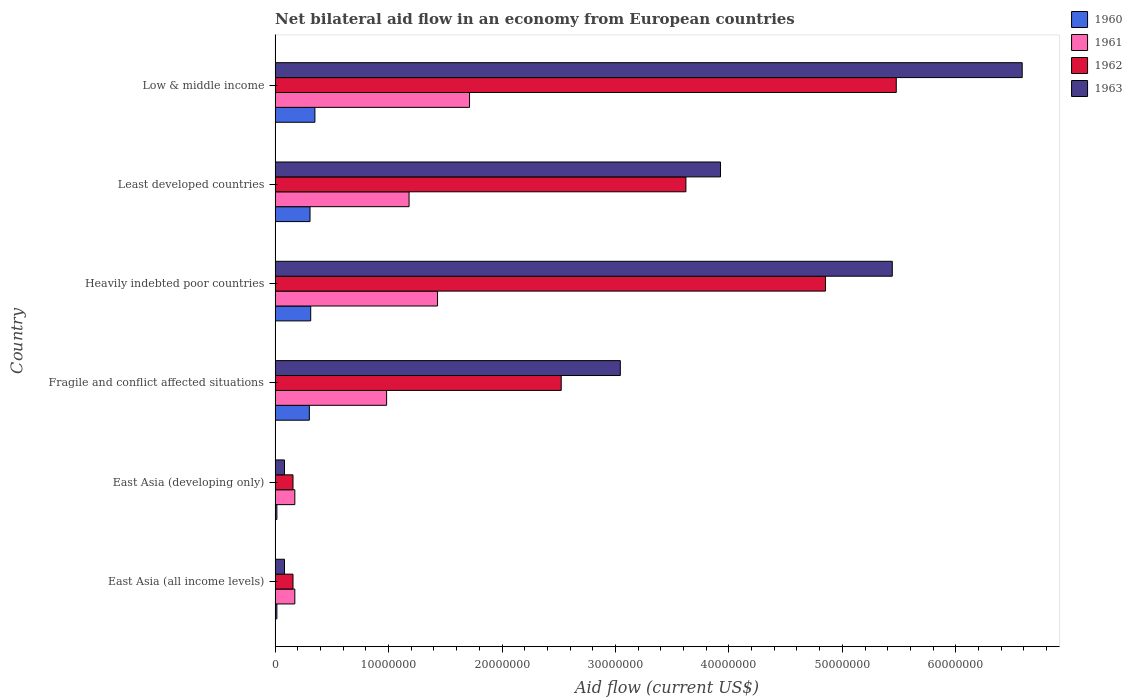How many groups of bars are there?
Your answer should be very brief. 6. Are the number of bars per tick equal to the number of legend labels?
Your answer should be very brief. Yes. Are the number of bars on each tick of the Y-axis equal?
Your response must be concise. Yes. How many bars are there on the 5th tick from the top?
Ensure brevity in your answer.  4. How many bars are there on the 5th tick from the bottom?
Keep it short and to the point. 4. In how many cases, is the number of bars for a given country not equal to the number of legend labels?
Make the answer very short. 0. What is the net bilateral aid flow in 1963 in Low & middle income?
Provide a succinct answer. 6.58e+07. Across all countries, what is the maximum net bilateral aid flow in 1963?
Provide a short and direct response. 6.58e+07. Across all countries, what is the minimum net bilateral aid flow in 1963?
Offer a very short reply. 8.30e+05. In which country was the net bilateral aid flow in 1963 minimum?
Your response must be concise. East Asia (all income levels). What is the total net bilateral aid flow in 1961 in the graph?
Your answer should be very brief. 5.66e+07. What is the difference between the net bilateral aid flow in 1961 in Heavily indebted poor countries and that in Least developed countries?
Your answer should be compact. 2.51e+06. What is the difference between the net bilateral aid flow in 1962 in Low & middle income and the net bilateral aid flow in 1963 in East Asia (all income levels)?
Your answer should be very brief. 5.39e+07. What is the average net bilateral aid flow in 1963 per country?
Provide a short and direct response. 3.19e+07. What is the difference between the net bilateral aid flow in 1960 and net bilateral aid flow in 1961 in Fragile and conflict affected situations?
Ensure brevity in your answer.  -6.81e+06. In how many countries, is the net bilateral aid flow in 1962 greater than 54000000 US$?
Keep it short and to the point. 1. What is the ratio of the net bilateral aid flow in 1960 in East Asia (developing only) to that in Least developed countries?
Provide a short and direct response. 0.05. What is the difference between the highest and the lowest net bilateral aid flow in 1963?
Make the answer very short. 6.50e+07. Is it the case that in every country, the sum of the net bilateral aid flow in 1960 and net bilateral aid flow in 1962 is greater than the sum of net bilateral aid flow in 1961 and net bilateral aid flow in 1963?
Provide a short and direct response. No. How many bars are there?
Keep it short and to the point. 24. How many countries are there in the graph?
Offer a terse response. 6. What is the difference between two consecutive major ticks on the X-axis?
Offer a very short reply. 1.00e+07. What is the title of the graph?
Your answer should be very brief. Net bilateral aid flow in an economy from European countries. Does "1986" appear as one of the legend labels in the graph?
Ensure brevity in your answer.  No. What is the label or title of the X-axis?
Offer a very short reply. Aid flow (current US$). What is the label or title of the Y-axis?
Ensure brevity in your answer.  Country. What is the Aid flow (current US$) of 1961 in East Asia (all income levels)?
Provide a succinct answer. 1.74e+06. What is the Aid flow (current US$) in 1962 in East Asia (all income levels)?
Ensure brevity in your answer.  1.58e+06. What is the Aid flow (current US$) in 1963 in East Asia (all income levels)?
Make the answer very short. 8.30e+05. What is the Aid flow (current US$) in 1961 in East Asia (developing only)?
Your response must be concise. 1.74e+06. What is the Aid flow (current US$) in 1962 in East Asia (developing only)?
Your answer should be compact. 1.58e+06. What is the Aid flow (current US$) of 1963 in East Asia (developing only)?
Provide a short and direct response. 8.30e+05. What is the Aid flow (current US$) of 1960 in Fragile and conflict affected situations?
Your response must be concise. 3.02e+06. What is the Aid flow (current US$) of 1961 in Fragile and conflict affected situations?
Give a very brief answer. 9.83e+06. What is the Aid flow (current US$) of 1962 in Fragile and conflict affected situations?
Your answer should be very brief. 2.52e+07. What is the Aid flow (current US$) in 1963 in Fragile and conflict affected situations?
Provide a succinct answer. 3.04e+07. What is the Aid flow (current US$) of 1960 in Heavily indebted poor countries?
Offer a very short reply. 3.14e+06. What is the Aid flow (current US$) in 1961 in Heavily indebted poor countries?
Give a very brief answer. 1.43e+07. What is the Aid flow (current US$) of 1962 in Heavily indebted poor countries?
Ensure brevity in your answer.  4.85e+07. What is the Aid flow (current US$) in 1963 in Heavily indebted poor countries?
Keep it short and to the point. 5.44e+07. What is the Aid flow (current US$) of 1960 in Least developed countries?
Ensure brevity in your answer.  3.08e+06. What is the Aid flow (current US$) of 1961 in Least developed countries?
Offer a very short reply. 1.18e+07. What is the Aid flow (current US$) of 1962 in Least developed countries?
Provide a succinct answer. 3.62e+07. What is the Aid flow (current US$) of 1963 in Least developed countries?
Make the answer very short. 3.93e+07. What is the Aid flow (current US$) in 1960 in Low & middle income?
Offer a very short reply. 3.51e+06. What is the Aid flow (current US$) in 1961 in Low & middle income?
Give a very brief answer. 1.71e+07. What is the Aid flow (current US$) of 1962 in Low & middle income?
Your response must be concise. 5.48e+07. What is the Aid flow (current US$) of 1963 in Low & middle income?
Make the answer very short. 6.58e+07. Across all countries, what is the maximum Aid flow (current US$) of 1960?
Provide a succinct answer. 3.51e+06. Across all countries, what is the maximum Aid flow (current US$) of 1961?
Your answer should be very brief. 1.71e+07. Across all countries, what is the maximum Aid flow (current US$) in 1962?
Your response must be concise. 5.48e+07. Across all countries, what is the maximum Aid flow (current US$) of 1963?
Offer a very short reply. 6.58e+07. Across all countries, what is the minimum Aid flow (current US$) in 1961?
Your response must be concise. 1.74e+06. Across all countries, what is the minimum Aid flow (current US$) in 1962?
Your answer should be compact. 1.58e+06. Across all countries, what is the minimum Aid flow (current US$) in 1963?
Your answer should be very brief. 8.30e+05. What is the total Aid flow (current US$) of 1960 in the graph?
Ensure brevity in your answer.  1.31e+07. What is the total Aid flow (current US$) in 1961 in the graph?
Keep it short and to the point. 5.66e+07. What is the total Aid flow (current US$) in 1962 in the graph?
Your response must be concise. 1.68e+08. What is the total Aid flow (current US$) in 1963 in the graph?
Your answer should be compact. 1.92e+08. What is the difference between the Aid flow (current US$) of 1961 in East Asia (all income levels) and that in East Asia (developing only)?
Offer a terse response. 0. What is the difference between the Aid flow (current US$) in 1962 in East Asia (all income levels) and that in East Asia (developing only)?
Make the answer very short. 0. What is the difference between the Aid flow (current US$) in 1963 in East Asia (all income levels) and that in East Asia (developing only)?
Your answer should be very brief. 0. What is the difference between the Aid flow (current US$) of 1960 in East Asia (all income levels) and that in Fragile and conflict affected situations?
Provide a short and direct response. -2.86e+06. What is the difference between the Aid flow (current US$) in 1961 in East Asia (all income levels) and that in Fragile and conflict affected situations?
Give a very brief answer. -8.09e+06. What is the difference between the Aid flow (current US$) in 1962 in East Asia (all income levels) and that in Fragile and conflict affected situations?
Your answer should be compact. -2.36e+07. What is the difference between the Aid flow (current US$) of 1963 in East Asia (all income levels) and that in Fragile and conflict affected situations?
Provide a short and direct response. -2.96e+07. What is the difference between the Aid flow (current US$) in 1960 in East Asia (all income levels) and that in Heavily indebted poor countries?
Give a very brief answer. -2.98e+06. What is the difference between the Aid flow (current US$) of 1961 in East Asia (all income levels) and that in Heavily indebted poor countries?
Offer a terse response. -1.26e+07. What is the difference between the Aid flow (current US$) of 1962 in East Asia (all income levels) and that in Heavily indebted poor countries?
Provide a short and direct response. -4.69e+07. What is the difference between the Aid flow (current US$) of 1963 in East Asia (all income levels) and that in Heavily indebted poor countries?
Give a very brief answer. -5.36e+07. What is the difference between the Aid flow (current US$) in 1960 in East Asia (all income levels) and that in Least developed countries?
Ensure brevity in your answer.  -2.92e+06. What is the difference between the Aid flow (current US$) in 1961 in East Asia (all income levels) and that in Least developed countries?
Offer a terse response. -1.01e+07. What is the difference between the Aid flow (current US$) of 1962 in East Asia (all income levels) and that in Least developed countries?
Your answer should be compact. -3.46e+07. What is the difference between the Aid flow (current US$) in 1963 in East Asia (all income levels) and that in Least developed countries?
Provide a short and direct response. -3.84e+07. What is the difference between the Aid flow (current US$) of 1960 in East Asia (all income levels) and that in Low & middle income?
Your response must be concise. -3.35e+06. What is the difference between the Aid flow (current US$) of 1961 in East Asia (all income levels) and that in Low & middle income?
Your answer should be compact. -1.54e+07. What is the difference between the Aid flow (current US$) of 1962 in East Asia (all income levels) and that in Low & middle income?
Provide a succinct answer. -5.32e+07. What is the difference between the Aid flow (current US$) in 1963 in East Asia (all income levels) and that in Low & middle income?
Keep it short and to the point. -6.50e+07. What is the difference between the Aid flow (current US$) of 1960 in East Asia (developing only) and that in Fragile and conflict affected situations?
Make the answer very short. -2.86e+06. What is the difference between the Aid flow (current US$) of 1961 in East Asia (developing only) and that in Fragile and conflict affected situations?
Ensure brevity in your answer.  -8.09e+06. What is the difference between the Aid flow (current US$) of 1962 in East Asia (developing only) and that in Fragile and conflict affected situations?
Keep it short and to the point. -2.36e+07. What is the difference between the Aid flow (current US$) of 1963 in East Asia (developing only) and that in Fragile and conflict affected situations?
Your answer should be very brief. -2.96e+07. What is the difference between the Aid flow (current US$) in 1960 in East Asia (developing only) and that in Heavily indebted poor countries?
Give a very brief answer. -2.98e+06. What is the difference between the Aid flow (current US$) in 1961 in East Asia (developing only) and that in Heavily indebted poor countries?
Ensure brevity in your answer.  -1.26e+07. What is the difference between the Aid flow (current US$) in 1962 in East Asia (developing only) and that in Heavily indebted poor countries?
Make the answer very short. -4.69e+07. What is the difference between the Aid flow (current US$) in 1963 in East Asia (developing only) and that in Heavily indebted poor countries?
Make the answer very short. -5.36e+07. What is the difference between the Aid flow (current US$) in 1960 in East Asia (developing only) and that in Least developed countries?
Keep it short and to the point. -2.92e+06. What is the difference between the Aid flow (current US$) of 1961 in East Asia (developing only) and that in Least developed countries?
Provide a succinct answer. -1.01e+07. What is the difference between the Aid flow (current US$) in 1962 in East Asia (developing only) and that in Least developed countries?
Keep it short and to the point. -3.46e+07. What is the difference between the Aid flow (current US$) of 1963 in East Asia (developing only) and that in Least developed countries?
Provide a short and direct response. -3.84e+07. What is the difference between the Aid flow (current US$) of 1960 in East Asia (developing only) and that in Low & middle income?
Make the answer very short. -3.35e+06. What is the difference between the Aid flow (current US$) in 1961 in East Asia (developing only) and that in Low & middle income?
Your answer should be compact. -1.54e+07. What is the difference between the Aid flow (current US$) of 1962 in East Asia (developing only) and that in Low & middle income?
Your answer should be compact. -5.32e+07. What is the difference between the Aid flow (current US$) of 1963 in East Asia (developing only) and that in Low & middle income?
Your answer should be compact. -6.50e+07. What is the difference between the Aid flow (current US$) in 1960 in Fragile and conflict affected situations and that in Heavily indebted poor countries?
Your answer should be compact. -1.20e+05. What is the difference between the Aid flow (current US$) of 1961 in Fragile and conflict affected situations and that in Heavily indebted poor countries?
Keep it short and to the point. -4.49e+06. What is the difference between the Aid flow (current US$) in 1962 in Fragile and conflict affected situations and that in Heavily indebted poor countries?
Provide a short and direct response. -2.33e+07. What is the difference between the Aid flow (current US$) of 1963 in Fragile and conflict affected situations and that in Heavily indebted poor countries?
Offer a terse response. -2.40e+07. What is the difference between the Aid flow (current US$) of 1960 in Fragile and conflict affected situations and that in Least developed countries?
Provide a succinct answer. -6.00e+04. What is the difference between the Aid flow (current US$) in 1961 in Fragile and conflict affected situations and that in Least developed countries?
Your response must be concise. -1.98e+06. What is the difference between the Aid flow (current US$) in 1962 in Fragile and conflict affected situations and that in Least developed countries?
Your answer should be compact. -1.10e+07. What is the difference between the Aid flow (current US$) in 1963 in Fragile and conflict affected situations and that in Least developed countries?
Your response must be concise. -8.83e+06. What is the difference between the Aid flow (current US$) of 1960 in Fragile and conflict affected situations and that in Low & middle income?
Offer a very short reply. -4.90e+05. What is the difference between the Aid flow (current US$) of 1961 in Fragile and conflict affected situations and that in Low & middle income?
Keep it short and to the point. -7.31e+06. What is the difference between the Aid flow (current US$) of 1962 in Fragile and conflict affected situations and that in Low & middle income?
Keep it short and to the point. -2.95e+07. What is the difference between the Aid flow (current US$) of 1963 in Fragile and conflict affected situations and that in Low & middle income?
Your answer should be compact. -3.54e+07. What is the difference between the Aid flow (current US$) of 1961 in Heavily indebted poor countries and that in Least developed countries?
Provide a succinct answer. 2.51e+06. What is the difference between the Aid flow (current US$) of 1962 in Heavily indebted poor countries and that in Least developed countries?
Your answer should be very brief. 1.23e+07. What is the difference between the Aid flow (current US$) of 1963 in Heavily indebted poor countries and that in Least developed countries?
Give a very brief answer. 1.51e+07. What is the difference between the Aid flow (current US$) in 1960 in Heavily indebted poor countries and that in Low & middle income?
Ensure brevity in your answer.  -3.70e+05. What is the difference between the Aid flow (current US$) in 1961 in Heavily indebted poor countries and that in Low & middle income?
Offer a terse response. -2.82e+06. What is the difference between the Aid flow (current US$) of 1962 in Heavily indebted poor countries and that in Low & middle income?
Keep it short and to the point. -6.24e+06. What is the difference between the Aid flow (current US$) of 1963 in Heavily indebted poor countries and that in Low & middle income?
Provide a short and direct response. -1.14e+07. What is the difference between the Aid flow (current US$) in 1960 in Least developed countries and that in Low & middle income?
Make the answer very short. -4.30e+05. What is the difference between the Aid flow (current US$) of 1961 in Least developed countries and that in Low & middle income?
Your answer should be very brief. -5.33e+06. What is the difference between the Aid flow (current US$) in 1962 in Least developed countries and that in Low & middle income?
Provide a short and direct response. -1.85e+07. What is the difference between the Aid flow (current US$) in 1963 in Least developed countries and that in Low & middle income?
Provide a succinct answer. -2.66e+07. What is the difference between the Aid flow (current US$) of 1960 in East Asia (all income levels) and the Aid flow (current US$) of 1961 in East Asia (developing only)?
Your response must be concise. -1.58e+06. What is the difference between the Aid flow (current US$) of 1960 in East Asia (all income levels) and the Aid flow (current US$) of 1962 in East Asia (developing only)?
Provide a short and direct response. -1.42e+06. What is the difference between the Aid flow (current US$) in 1960 in East Asia (all income levels) and the Aid flow (current US$) in 1963 in East Asia (developing only)?
Provide a succinct answer. -6.70e+05. What is the difference between the Aid flow (current US$) of 1961 in East Asia (all income levels) and the Aid flow (current US$) of 1963 in East Asia (developing only)?
Ensure brevity in your answer.  9.10e+05. What is the difference between the Aid flow (current US$) of 1962 in East Asia (all income levels) and the Aid flow (current US$) of 1963 in East Asia (developing only)?
Offer a very short reply. 7.50e+05. What is the difference between the Aid flow (current US$) of 1960 in East Asia (all income levels) and the Aid flow (current US$) of 1961 in Fragile and conflict affected situations?
Keep it short and to the point. -9.67e+06. What is the difference between the Aid flow (current US$) of 1960 in East Asia (all income levels) and the Aid flow (current US$) of 1962 in Fragile and conflict affected situations?
Your answer should be compact. -2.51e+07. What is the difference between the Aid flow (current US$) of 1960 in East Asia (all income levels) and the Aid flow (current US$) of 1963 in Fragile and conflict affected situations?
Offer a very short reply. -3.03e+07. What is the difference between the Aid flow (current US$) in 1961 in East Asia (all income levels) and the Aid flow (current US$) in 1962 in Fragile and conflict affected situations?
Your answer should be very brief. -2.35e+07. What is the difference between the Aid flow (current US$) of 1961 in East Asia (all income levels) and the Aid flow (current US$) of 1963 in Fragile and conflict affected situations?
Give a very brief answer. -2.87e+07. What is the difference between the Aid flow (current US$) in 1962 in East Asia (all income levels) and the Aid flow (current US$) in 1963 in Fragile and conflict affected situations?
Offer a very short reply. -2.88e+07. What is the difference between the Aid flow (current US$) in 1960 in East Asia (all income levels) and the Aid flow (current US$) in 1961 in Heavily indebted poor countries?
Your answer should be compact. -1.42e+07. What is the difference between the Aid flow (current US$) in 1960 in East Asia (all income levels) and the Aid flow (current US$) in 1962 in Heavily indebted poor countries?
Provide a short and direct response. -4.84e+07. What is the difference between the Aid flow (current US$) in 1960 in East Asia (all income levels) and the Aid flow (current US$) in 1963 in Heavily indebted poor countries?
Offer a very short reply. -5.42e+07. What is the difference between the Aid flow (current US$) in 1961 in East Asia (all income levels) and the Aid flow (current US$) in 1962 in Heavily indebted poor countries?
Offer a very short reply. -4.68e+07. What is the difference between the Aid flow (current US$) of 1961 in East Asia (all income levels) and the Aid flow (current US$) of 1963 in Heavily indebted poor countries?
Keep it short and to the point. -5.27e+07. What is the difference between the Aid flow (current US$) of 1962 in East Asia (all income levels) and the Aid flow (current US$) of 1963 in Heavily indebted poor countries?
Offer a very short reply. -5.28e+07. What is the difference between the Aid flow (current US$) in 1960 in East Asia (all income levels) and the Aid flow (current US$) in 1961 in Least developed countries?
Keep it short and to the point. -1.16e+07. What is the difference between the Aid flow (current US$) in 1960 in East Asia (all income levels) and the Aid flow (current US$) in 1962 in Least developed countries?
Make the answer very short. -3.60e+07. What is the difference between the Aid flow (current US$) of 1960 in East Asia (all income levels) and the Aid flow (current US$) of 1963 in Least developed countries?
Keep it short and to the point. -3.91e+07. What is the difference between the Aid flow (current US$) in 1961 in East Asia (all income levels) and the Aid flow (current US$) in 1962 in Least developed countries?
Ensure brevity in your answer.  -3.45e+07. What is the difference between the Aid flow (current US$) of 1961 in East Asia (all income levels) and the Aid flow (current US$) of 1963 in Least developed countries?
Keep it short and to the point. -3.75e+07. What is the difference between the Aid flow (current US$) of 1962 in East Asia (all income levels) and the Aid flow (current US$) of 1963 in Least developed countries?
Make the answer very short. -3.77e+07. What is the difference between the Aid flow (current US$) in 1960 in East Asia (all income levels) and the Aid flow (current US$) in 1961 in Low & middle income?
Keep it short and to the point. -1.70e+07. What is the difference between the Aid flow (current US$) of 1960 in East Asia (all income levels) and the Aid flow (current US$) of 1962 in Low & middle income?
Your answer should be compact. -5.46e+07. What is the difference between the Aid flow (current US$) of 1960 in East Asia (all income levels) and the Aid flow (current US$) of 1963 in Low & middle income?
Offer a very short reply. -6.57e+07. What is the difference between the Aid flow (current US$) in 1961 in East Asia (all income levels) and the Aid flow (current US$) in 1962 in Low & middle income?
Your answer should be very brief. -5.30e+07. What is the difference between the Aid flow (current US$) in 1961 in East Asia (all income levels) and the Aid flow (current US$) in 1963 in Low & middle income?
Provide a succinct answer. -6.41e+07. What is the difference between the Aid flow (current US$) in 1962 in East Asia (all income levels) and the Aid flow (current US$) in 1963 in Low & middle income?
Make the answer very short. -6.43e+07. What is the difference between the Aid flow (current US$) of 1960 in East Asia (developing only) and the Aid flow (current US$) of 1961 in Fragile and conflict affected situations?
Keep it short and to the point. -9.67e+06. What is the difference between the Aid flow (current US$) of 1960 in East Asia (developing only) and the Aid flow (current US$) of 1962 in Fragile and conflict affected situations?
Keep it short and to the point. -2.51e+07. What is the difference between the Aid flow (current US$) in 1960 in East Asia (developing only) and the Aid flow (current US$) in 1963 in Fragile and conflict affected situations?
Ensure brevity in your answer.  -3.03e+07. What is the difference between the Aid flow (current US$) in 1961 in East Asia (developing only) and the Aid flow (current US$) in 1962 in Fragile and conflict affected situations?
Offer a terse response. -2.35e+07. What is the difference between the Aid flow (current US$) in 1961 in East Asia (developing only) and the Aid flow (current US$) in 1963 in Fragile and conflict affected situations?
Provide a short and direct response. -2.87e+07. What is the difference between the Aid flow (current US$) in 1962 in East Asia (developing only) and the Aid flow (current US$) in 1963 in Fragile and conflict affected situations?
Provide a short and direct response. -2.88e+07. What is the difference between the Aid flow (current US$) in 1960 in East Asia (developing only) and the Aid flow (current US$) in 1961 in Heavily indebted poor countries?
Give a very brief answer. -1.42e+07. What is the difference between the Aid flow (current US$) in 1960 in East Asia (developing only) and the Aid flow (current US$) in 1962 in Heavily indebted poor countries?
Provide a succinct answer. -4.84e+07. What is the difference between the Aid flow (current US$) of 1960 in East Asia (developing only) and the Aid flow (current US$) of 1963 in Heavily indebted poor countries?
Offer a terse response. -5.42e+07. What is the difference between the Aid flow (current US$) in 1961 in East Asia (developing only) and the Aid flow (current US$) in 1962 in Heavily indebted poor countries?
Offer a very short reply. -4.68e+07. What is the difference between the Aid flow (current US$) of 1961 in East Asia (developing only) and the Aid flow (current US$) of 1963 in Heavily indebted poor countries?
Give a very brief answer. -5.27e+07. What is the difference between the Aid flow (current US$) of 1962 in East Asia (developing only) and the Aid flow (current US$) of 1963 in Heavily indebted poor countries?
Offer a very short reply. -5.28e+07. What is the difference between the Aid flow (current US$) of 1960 in East Asia (developing only) and the Aid flow (current US$) of 1961 in Least developed countries?
Provide a succinct answer. -1.16e+07. What is the difference between the Aid flow (current US$) in 1960 in East Asia (developing only) and the Aid flow (current US$) in 1962 in Least developed countries?
Keep it short and to the point. -3.60e+07. What is the difference between the Aid flow (current US$) in 1960 in East Asia (developing only) and the Aid flow (current US$) in 1963 in Least developed countries?
Offer a terse response. -3.91e+07. What is the difference between the Aid flow (current US$) in 1961 in East Asia (developing only) and the Aid flow (current US$) in 1962 in Least developed countries?
Ensure brevity in your answer.  -3.45e+07. What is the difference between the Aid flow (current US$) of 1961 in East Asia (developing only) and the Aid flow (current US$) of 1963 in Least developed countries?
Make the answer very short. -3.75e+07. What is the difference between the Aid flow (current US$) of 1962 in East Asia (developing only) and the Aid flow (current US$) of 1963 in Least developed countries?
Provide a short and direct response. -3.77e+07. What is the difference between the Aid flow (current US$) of 1960 in East Asia (developing only) and the Aid flow (current US$) of 1961 in Low & middle income?
Your answer should be very brief. -1.70e+07. What is the difference between the Aid flow (current US$) in 1960 in East Asia (developing only) and the Aid flow (current US$) in 1962 in Low & middle income?
Make the answer very short. -5.46e+07. What is the difference between the Aid flow (current US$) of 1960 in East Asia (developing only) and the Aid flow (current US$) of 1963 in Low & middle income?
Ensure brevity in your answer.  -6.57e+07. What is the difference between the Aid flow (current US$) of 1961 in East Asia (developing only) and the Aid flow (current US$) of 1962 in Low & middle income?
Provide a succinct answer. -5.30e+07. What is the difference between the Aid flow (current US$) of 1961 in East Asia (developing only) and the Aid flow (current US$) of 1963 in Low & middle income?
Provide a succinct answer. -6.41e+07. What is the difference between the Aid flow (current US$) of 1962 in East Asia (developing only) and the Aid flow (current US$) of 1963 in Low & middle income?
Give a very brief answer. -6.43e+07. What is the difference between the Aid flow (current US$) of 1960 in Fragile and conflict affected situations and the Aid flow (current US$) of 1961 in Heavily indebted poor countries?
Your answer should be very brief. -1.13e+07. What is the difference between the Aid flow (current US$) of 1960 in Fragile and conflict affected situations and the Aid flow (current US$) of 1962 in Heavily indebted poor countries?
Provide a short and direct response. -4.55e+07. What is the difference between the Aid flow (current US$) of 1960 in Fragile and conflict affected situations and the Aid flow (current US$) of 1963 in Heavily indebted poor countries?
Keep it short and to the point. -5.14e+07. What is the difference between the Aid flow (current US$) in 1961 in Fragile and conflict affected situations and the Aid flow (current US$) in 1962 in Heavily indebted poor countries?
Ensure brevity in your answer.  -3.87e+07. What is the difference between the Aid flow (current US$) of 1961 in Fragile and conflict affected situations and the Aid flow (current US$) of 1963 in Heavily indebted poor countries?
Ensure brevity in your answer.  -4.46e+07. What is the difference between the Aid flow (current US$) of 1962 in Fragile and conflict affected situations and the Aid flow (current US$) of 1963 in Heavily indebted poor countries?
Provide a succinct answer. -2.92e+07. What is the difference between the Aid flow (current US$) in 1960 in Fragile and conflict affected situations and the Aid flow (current US$) in 1961 in Least developed countries?
Offer a terse response. -8.79e+06. What is the difference between the Aid flow (current US$) in 1960 in Fragile and conflict affected situations and the Aid flow (current US$) in 1962 in Least developed countries?
Offer a very short reply. -3.32e+07. What is the difference between the Aid flow (current US$) in 1960 in Fragile and conflict affected situations and the Aid flow (current US$) in 1963 in Least developed countries?
Provide a succinct answer. -3.62e+07. What is the difference between the Aid flow (current US$) in 1961 in Fragile and conflict affected situations and the Aid flow (current US$) in 1962 in Least developed countries?
Offer a very short reply. -2.64e+07. What is the difference between the Aid flow (current US$) in 1961 in Fragile and conflict affected situations and the Aid flow (current US$) in 1963 in Least developed countries?
Keep it short and to the point. -2.94e+07. What is the difference between the Aid flow (current US$) of 1962 in Fragile and conflict affected situations and the Aid flow (current US$) of 1963 in Least developed countries?
Offer a terse response. -1.40e+07. What is the difference between the Aid flow (current US$) in 1960 in Fragile and conflict affected situations and the Aid flow (current US$) in 1961 in Low & middle income?
Provide a short and direct response. -1.41e+07. What is the difference between the Aid flow (current US$) in 1960 in Fragile and conflict affected situations and the Aid flow (current US$) in 1962 in Low & middle income?
Give a very brief answer. -5.17e+07. What is the difference between the Aid flow (current US$) in 1960 in Fragile and conflict affected situations and the Aid flow (current US$) in 1963 in Low & middle income?
Give a very brief answer. -6.28e+07. What is the difference between the Aid flow (current US$) in 1961 in Fragile and conflict affected situations and the Aid flow (current US$) in 1962 in Low & middle income?
Give a very brief answer. -4.49e+07. What is the difference between the Aid flow (current US$) in 1961 in Fragile and conflict affected situations and the Aid flow (current US$) in 1963 in Low & middle income?
Your answer should be compact. -5.60e+07. What is the difference between the Aid flow (current US$) of 1962 in Fragile and conflict affected situations and the Aid flow (current US$) of 1963 in Low & middle income?
Your response must be concise. -4.06e+07. What is the difference between the Aid flow (current US$) in 1960 in Heavily indebted poor countries and the Aid flow (current US$) in 1961 in Least developed countries?
Offer a terse response. -8.67e+06. What is the difference between the Aid flow (current US$) of 1960 in Heavily indebted poor countries and the Aid flow (current US$) of 1962 in Least developed countries?
Keep it short and to the point. -3.31e+07. What is the difference between the Aid flow (current US$) of 1960 in Heavily indebted poor countries and the Aid flow (current US$) of 1963 in Least developed countries?
Give a very brief answer. -3.61e+07. What is the difference between the Aid flow (current US$) in 1961 in Heavily indebted poor countries and the Aid flow (current US$) in 1962 in Least developed countries?
Provide a succinct answer. -2.19e+07. What is the difference between the Aid flow (current US$) of 1961 in Heavily indebted poor countries and the Aid flow (current US$) of 1963 in Least developed countries?
Offer a terse response. -2.49e+07. What is the difference between the Aid flow (current US$) in 1962 in Heavily indebted poor countries and the Aid flow (current US$) in 1963 in Least developed countries?
Offer a terse response. 9.25e+06. What is the difference between the Aid flow (current US$) of 1960 in Heavily indebted poor countries and the Aid flow (current US$) of 1961 in Low & middle income?
Ensure brevity in your answer.  -1.40e+07. What is the difference between the Aid flow (current US$) in 1960 in Heavily indebted poor countries and the Aid flow (current US$) in 1962 in Low & middle income?
Offer a terse response. -5.16e+07. What is the difference between the Aid flow (current US$) of 1960 in Heavily indebted poor countries and the Aid flow (current US$) of 1963 in Low & middle income?
Your answer should be very brief. -6.27e+07. What is the difference between the Aid flow (current US$) of 1961 in Heavily indebted poor countries and the Aid flow (current US$) of 1962 in Low & middle income?
Make the answer very short. -4.04e+07. What is the difference between the Aid flow (current US$) of 1961 in Heavily indebted poor countries and the Aid flow (current US$) of 1963 in Low & middle income?
Your answer should be compact. -5.15e+07. What is the difference between the Aid flow (current US$) in 1962 in Heavily indebted poor countries and the Aid flow (current US$) in 1963 in Low & middle income?
Provide a short and direct response. -1.73e+07. What is the difference between the Aid flow (current US$) in 1960 in Least developed countries and the Aid flow (current US$) in 1961 in Low & middle income?
Give a very brief answer. -1.41e+07. What is the difference between the Aid flow (current US$) in 1960 in Least developed countries and the Aid flow (current US$) in 1962 in Low & middle income?
Offer a terse response. -5.17e+07. What is the difference between the Aid flow (current US$) of 1960 in Least developed countries and the Aid flow (current US$) of 1963 in Low & middle income?
Keep it short and to the point. -6.28e+07. What is the difference between the Aid flow (current US$) in 1961 in Least developed countries and the Aid flow (current US$) in 1962 in Low & middle income?
Keep it short and to the point. -4.29e+07. What is the difference between the Aid flow (current US$) in 1961 in Least developed countries and the Aid flow (current US$) in 1963 in Low & middle income?
Ensure brevity in your answer.  -5.40e+07. What is the difference between the Aid flow (current US$) of 1962 in Least developed countries and the Aid flow (current US$) of 1963 in Low & middle income?
Make the answer very short. -2.96e+07. What is the average Aid flow (current US$) in 1960 per country?
Make the answer very short. 2.18e+06. What is the average Aid flow (current US$) in 1961 per country?
Offer a very short reply. 9.43e+06. What is the average Aid flow (current US$) of 1962 per country?
Offer a very short reply. 2.80e+07. What is the average Aid flow (current US$) of 1963 per country?
Keep it short and to the point. 3.19e+07. What is the difference between the Aid flow (current US$) of 1960 and Aid flow (current US$) of 1961 in East Asia (all income levels)?
Provide a succinct answer. -1.58e+06. What is the difference between the Aid flow (current US$) in 1960 and Aid flow (current US$) in 1962 in East Asia (all income levels)?
Make the answer very short. -1.42e+06. What is the difference between the Aid flow (current US$) in 1960 and Aid flow (current US$) in 1963 in East Asia (all income levels)?
Your response must be concise. -6.70e+05. What is the difference between the Aid flow (current US$) in 1961 and Aid flow (current US$) in 1962 in East Asia (all income levels)?
Offer a very short reply. 1.60e+05. What is the difference between the Aid flow (current US$) of 1961 and Aid flow (current US$) of 1963 in East Asia (all income levels)?
Your response must be concise. 9.10e+05. What is the difference between the Aid flow (current US$) of 1962 and Aid flow (current US$) of 1963 in East Asia (all income levels)?
Keep it short and to the point. 7.50e+05. What is the difference between the Aid flow (current US$) in 1960 and Aid flow (current US$) in 1961 in East Asia (developing only)?
Offer a terse response. -1.58e+06. What is the difference between the Aid flow (current US$) of 1960 and Aid flow (current US$) of 1962 in East Asia (developing only)?
Ensure brevity in your answer.  -1.42e+06. What is the difference between the Aid flow (current US$) of 1960 and Aid flow (current US$) of 1963 in East Asia (developing only)?
Ensure brevity in your answer.  -6.70e+05. What is the difference between the Aid flow (current US$) of 1961 and Aid flow (current US$) of 1962 in East Asia (developing only)?
Offer a terse response. 1.60e+05. What is the difference between the Aid flow (current US$) of 1961 and Aid flow (current US$) of 1963 in East Asia (developing only)?
Keep it short and to the point. 9.10e+05. What is the difference between the Aid flow (current US$) in 1962 and Aid flow (current US$) in 1963 in East Asia (developing only)?
Offer a terse response. 7.50e+05. What is the difference between the Aid flow (current US$) in 1960 and Aid flow (current US$) in 1961 in Fragile and conflict affected situations?
Make the answer very short. -6.81e+06. What is the difference between the Aid flow (current US$) of 1960 and Aid flow (current US$) of 1962 in Fragile and conflict affected situations?
Make the answer very short. -2.22e+07. What is the difference between the Aid flow (current US$) in 1960 and Aid flow (current US$) in 1963 in Fragile and conflict affected situations?
Your answer should be compact. -2.74e+07. What is the difference between the Aid flow (current US$) in 1961 and Aid flow (current US$) in 1962 in Fragile and conflict affected situations?
Offer a very short reply. -1.54e+07. What is the difference between the Aid flow (current US$) in 1961 and Aid flow (current US$) in 1963 in Fragile and conflict affected situations?
Ensure brevity in your answer.  -2.06e+07. What is the difference between the Aid flow (current US$) of 1962 and Aid flow (current US$) of 1963 in Fragile and conflict affected situations?
Provide a short and direct response. -5.21e+06. What is the difference between the Aid flow (current US$) of 1960 and Aid flow (current US$) of 1961 in Heavily indebted poor countries?
Your answer should be very brief. -1.12e+07. What is the difference between the Aid flow (current US$) of 1960 and Aid flow (current US$) of 1962 in Heavily indebted poor countries?
Offer a terse response. -4.54e+07. What is the difference between the Aid flow (current US$) in 1960 and Aid flow (current US$) in 1963 in Heavily indebted poor countries?
Your answer should be very brief. -5.13e+07. What is the difference between the Aid flow (current US$) in 1961 and Aid flow (current US$) in 1962 in Heavily indebted poor countries?
Your answer should be compact. -3.42e+07. What is the difference between the Aid flow (current US$) in 1961 and Aid flow (current US$) in 1963 in Heavily indebted poor countries?
Ensure brevity in your answer.  -4.01e+07. What is the difference between the Aid flow (current US$) in 1962 and Aid flow (current US$) in 1963 in Heavily indebted poor countries?
Your answer should be very brief. -5.89e+06. What is the difference between the Aid flow (current US$) of 1960 and Aid flow (current US$) of 1961 in Least developed countries?
Your answer should be very brief. -8.73e+06. What is the difference between the Aid flow (current US$) of 1960 and Aid flow (current US$) of 1962 in Least developed countries?
Keep it short and to the point. -3.31e+07. What is the difference between the Aid flow (current US$) in 1960 and Aid flow (current US$) in 1963 in Least developed countries?
Provide a short and direct response. -3.62e+07. What is the difference between the Aid flow (current US$) in 1961 and Aid flow (current US$) in 1962 in Least developed countries?
Your answer should be very brief. -2.44e+07. What is the difference between the Aid flow (current US$) in 1961 and Aid flow (current US$) in 1963 in Least developed countries?
Make the answer very short. -2.74e+07. What is the difference between the Aid flow (current US$) in 1962 and Aid flow (current US$) in 1963 in Least developed countries?
Give a very brief answer. -3.05e+06. What is the difference between the Aid flow (current US$) of 1960 and Aid flow (current US$) of 1961 in Low & middle income?
Ensure brevity in your answer.  -1.36e+07. What is the difference between the Aid flow (current US$) of 1960 and Aid flow (current US$) of 1962 in Low & middle income?
Offer a very short reply. -5.12e+07. What is the difference between the Aid flow (current US$) in 1960 and Aid flow (current US$) in 1963 in Low & middle income?
Ensure brevity in your answer.  -6.23e+07. What is the difference between the Aid flow (current US$) in 1961 and Aid flow (current US$) in 1962 in Low & middle income?
Offer a very short reply. -3.76e+07. What is the difference between the Aid flow (current US$) in 1961 and Aid flow (current US$) in 1963 in Low & middle income?
Offer a very short reply. -4.87e+07. What is the difference between the Aid flow (current US$) of 1962 and Aid flow (current US$) of 1963 in Low & middle income?
Your answer should be compact. -1.11e+07. What is the ratio of the Aid flow (current US$) in 1961 in East Asia (all income levels) to that in East Asia (developing only)?
Your answer should be compact. 1. What is the ratio of the Aid flow (current US$) of 1962 in East Asia (all income levels) to that in East Asia (developing only)?
Keep it short and to the point. 1. What is the ratio of the Aid flow (current US$) of 1960 in East Asia (all income levels) to that in Fragile and conflict affected situations?
Your answer should be very brief. 0.05. What is the ratio of the Aid flow (current US$) of 1961 in East Asia (all income levels) to that in Fragile and conflict affected situations?
Your response must be concise. 0.18. What is the ratio of the Aid flow (current US$) of 1962 in East Asia (all income levels) to that in Fragile and conflict affected situations?
Provide a short and direct response. 0.06. What is the ratio of the Aid flow (current US$) in 1963 in East Asia (all income levels) to that in Fragile and conflict affected situations?
Keep it short and to the point. 0.03. What is the ratio of the Aid flow (current US$) of 1960 in East Asia (all income levels) to that in Heavily indebted poor countries?
Keep it short and to the point. 0.05. What is the ratio of the Aid flow (current US$) in 1961 in East Asia (all income levels) to that in Heavily indebted poor countries?
Provide a short and direct response. 0.12. What is the ratio of the Aid flow (current US$) of 1962 in East Asia (all income levels) to that in Heavily indebted poor countries?
Your response must be concise. 0.03. What is the ratio of the Aid flow (current US$) in 1963 in East Asia (all income levels) to that in Heavily indebted poor countries?
Make the answer very short. 0.02. What is the ratio of the Aid flow (current US$) of 1960 in East Asia (all income levels) to that in Least developed countries?
Make the answer very short. 0.05. What is the ratio of the Aid flow (current US$) in 1961 in East Asia (all income levels) to that in Least developed countries?
Provide a succinct answer. 0.15. What is the ratio of the Aid flow (current US$) in 1962 in East Asia (all income levels) to that in Least developed countries?
Your answer should be compact. 0.04. What is the ratio of the Aid flow (current US$) in 1963 in East Asia (all income levels) to that in Least developed countries?
Offer a very short reply. 0.02. What is the ratio of the Aid flow (current US$) in 1960 in East Asia (all income levels) to that in Low & middle income?
Make the answer very short. 0.05. What is the ratio of the Aid flow (current US$) in 1961 in East Asia (all income levels) to that in Low & middle income?
Offer a very short reply. 0.1. What is the ratio of the Aid flow (current US$) in 1962 in East Asia (all income levels) to that in Low & middle income?
Give a very brief answer. 0.03. What is the ratio of the Aid flow (current US$) of 1963 in East Asia (all income levels) to that in Low & middle income?
Give a very brief answer. 0.01. What is the ratio of the Aid flow (current US$) in 1960 in East Asia (developing only) to that in Fragile and conflict affected situations?
Provide a short and direct response. 0.05. What is the ratio of the Aid flow (current US$) of 1961 in East Asia (developing only) to that in Fragile and conflict affected situations?
Offer a terse response. 0.18. What is the ratio of the Aid flow (current US$) of 1962 in East Asia (developing only) to that in Fragile and conflict affected situations?
Your answer should be very brief. 0.06. What is the ratio of the Aid flow (current US$) in 1963 in East Asia (developing only) to that in Fragile and conflict affected situations?
Offer a terse response. 0.03. What is the ratio of the Aid flow (current US$) in 1960 in East Asia (developing only) to that in Heavily indebted poor countries?
Ensure brevity in your answer.  0.05. What is the ratio of the Aid flow (current US$) of 1961 in East Asia (developing only) to that in Heavily indebted poor countries?
Provide a succinct answer. 0.12. What is the ratio of the Aid flow (current US$) of 1962 in East Asia (developing only) to that in Heavily indebted poor countries?
Give a very brief answer. 0.03. What is the ratio of the Aid flow (current US$) of 1963 in East Asia (developing only) to that in Heavily indebted poor countries?
Ensure brevity in your answer.  0.02. What is the ratio of the Aid flow (current US$) in 1960 in East Asia (developing only) to that in Least developed countries?
Your answer should be compact. 0.05. What is the ratio of the Aid flow (current US$) in 1961 in East Asia (developing only) to that in Least developed countries?
Provide a short and direct response. 0.15. What is the ratio of the Aid flow (current US$) of 1962 in East Asia (developing only) to that in Least developed countries?
Your answer should be compact. 0.04. What is the ratio of the Aid flow (current US$) in 1963 in East Asia (developing only) to that in Least developed countries?
Your answer should be very brief. 0.02. What is the ratio of the Aid flow (current US$) in 1960 in East Asia (developing only) to that in Low & middle income?
Ensure brevity in your answer.  0.05. What is the ratio of the Aid flow (current US$) of 1961 in East Asia (developing only) to that in Low & middle income?
Offer a terse response. 0.1. What is the ratio of the Aid flow (current US$) in 1962 in East Asia (developing only) to that in Low & middle income?
Keep it short and to the point. 0.03. What is the ratio of the Aid flow (current US$) in 1963 in East Asia (developing only) to that in Low & middle income?
Provide a succinct answer. 0.01. What is the ratio of the Aid flow (current US$) in 1960 in Fragile and conflict affected situations to that in Heavily indebted poor countries?
Ensure brevity in your answer.  0.96. What is the ratio of the Aid flow (current US$) in 1961 in Fragile and conflict affected situations to that in Heavily indebted poor countries?
Give a very brief answer. 0.69. What is the ratio of the Aid flow (current US$) of 1962 in Fragile and conflict affected situations to that in Heavily indebted poor countries?
Ensure brevity in your answer.  0.52. What is the ratio of the Aid flow (current US$) of 1963 in Fragile and conflict affected situations to that in Heavily indebted poor countries?
Give a very brief answer. 0.56. What is the ratio of the Aid flow (current US$) in 1960 in Fragile and conflict affected situations to that in Least developed countries?
Provide a short and direct response. 0.98. What is the ratio of the Aid flow (current US$) of 1961 in Fragile and conflict affected situations to that in Least developed countries?
Provide a short and direct response. 0.83. What is the ratio of the Aid flow (current US$) of 1962 in Fragile and conflict affected situations to that in Least developed countries?
Make the answer very short. 0.7. What is the ratio of the Aid flow (current US$) in 1963 in Fragile and conflict affected situations to that in Least developed countries?
Offer a very short reply. 0.78. What is the ratio of the Aid flow (current US$) in 1960 in Fragile and conflict affected situations to that in Low & middle income?
Provide a succinct answer. 0.86. What is the ratio of the Aid flow (current US$) in 1961 in Fragile and conflict affected situations to that in Low & middle income?
Offer a very short reply. 0.57. What is the ratio of the Aid flow (current US$) of 1962 in Fragile and conflict affected situations to that in Low & middle income?
Provide a short and direct response. 0.46. What is the ratio of the Aid flow (current US$) of 1963 in Fragile and conflict affected situations to that in Low & middle income?
Your answer should be very brief. 0.46. What is the ratio of the Aid flow (current US$) in 1960 in Heavily indebted poor countries to that in Least developed countries?
Keep it short and to the point. 1.02. What is the ratio of the Aid flow (current US$) in 1961 in Heavily indebted poor countries to that in Least developed countries?
Provide a succinct answer. 1.21. What is the ratio of the Aid flow (current US$) of 1962 in Heavily indebted poor countries to that in Least developed countries?
Offer a terse response. 1.34. What is the ratio of the Aid flow (current US$) of 1963 in Heavily indebted poor countries to that in Least developed countries?
Provide a short and direct response. 1.39. What is the ratio of the Aid flow (current US$) in 1960 in Heavily indebted poor countries to that in Low & middle income?
Your answer should be very brief. 0.89. What is the ratio of the Aid flow (current US$) of 1961 in Heavily indebted poor countries to that in Low & middle income?
Provide a short and direct response. 0.84. What is the ratio of the Aid flow (current US$) in 1962 in Heavily indebted poor countries to that in Low & middle income?
Your answer should be very brief. 0.89. What is the ratio of the Aid flow (current US$) in 1963 in Heavily indebted poor countries to that in Low & middle income?
Provide a short and direct response. 0.83. What is the ratio of the Aid flow (current US$) of 1960 in Least developed countries to that in Low & middle income?
Make the answer very short. 0.88. What is the ratio of the Aid flow (current US$) in 1961 in Least developed countries to that in Low & middle income?
Offer a very short reply. 0.69. What is the ratio of the Aid flow (current US$) of 1962 in Least developed countries to that in Low & middle income?
Keep it short and to the point. 0.66. What is the ratio of the Aid flow (current US$) in 1963 in Least developed countries to that in Low & middle income?
Give a very brief answer. 0.6. What is the difference between the highest and the second highest Aid flow (current US$) of 1960?
Your answer should be compact. 3.70e+05. What is the difference between the highest and the second highest Aid flow (current US$) in 1961?
Your response must be concise. 2.82e+06. What is the difference between the highest and the second highest Aid flow (current US$) in 1962?
Offer a very short reply. 6.24e+06. What is the difference between the highest and the second highest Aid flow (current US$) of 1963?
Give a very brief answer. 1.14e+07. What is the difference between the highest and the lowest Aid flow (current US$) in 1960?
Offer a very short reply. 3.35e+06. What is the difference between the highest and the lowest Aid flow (current US$) of 1961?
Ensure brevity in your answer.  1.54e+07. What is the difference between the highest and the lowest Aid flow (current US$) of 1962?
Your answer should be very brief. 5.32e+07. What is the difference between the highest and the lowest Aid flow (current US$) in 1963?
Make the answer very short. 6.50e+07. 